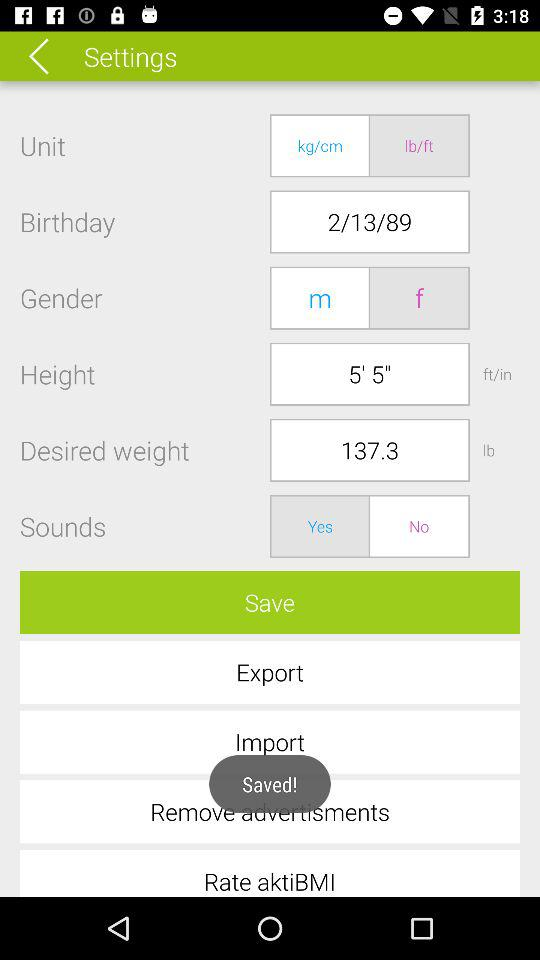What is the birth date? The birth date is February 13, 1989. 